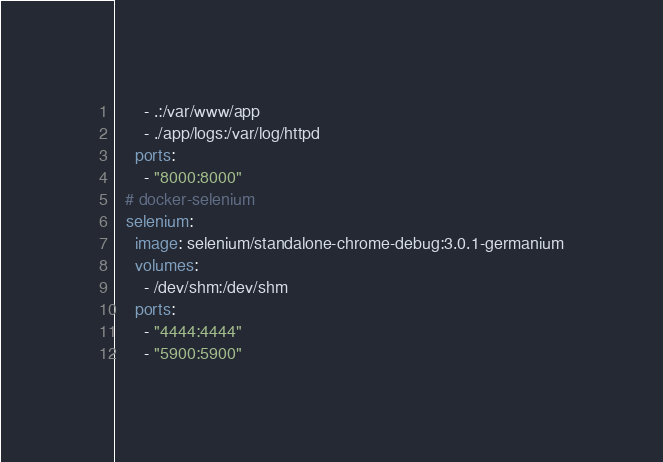<code> <loc_0><loc_0><loc_500><loc_500><_YAML_>      - .:/var/www/app
      - ./app/logs:/var/log/httpd
    ports:
      - "8000:8000"
  # docker-selenium
  selenium:
    image: selenium/standalone-chrome-debug:3.0.1-germanium
    volumes:
      - /dev/shm:/dev/shm
    ports:
      - "4444:4444"
      - "5900:5900"</code> 